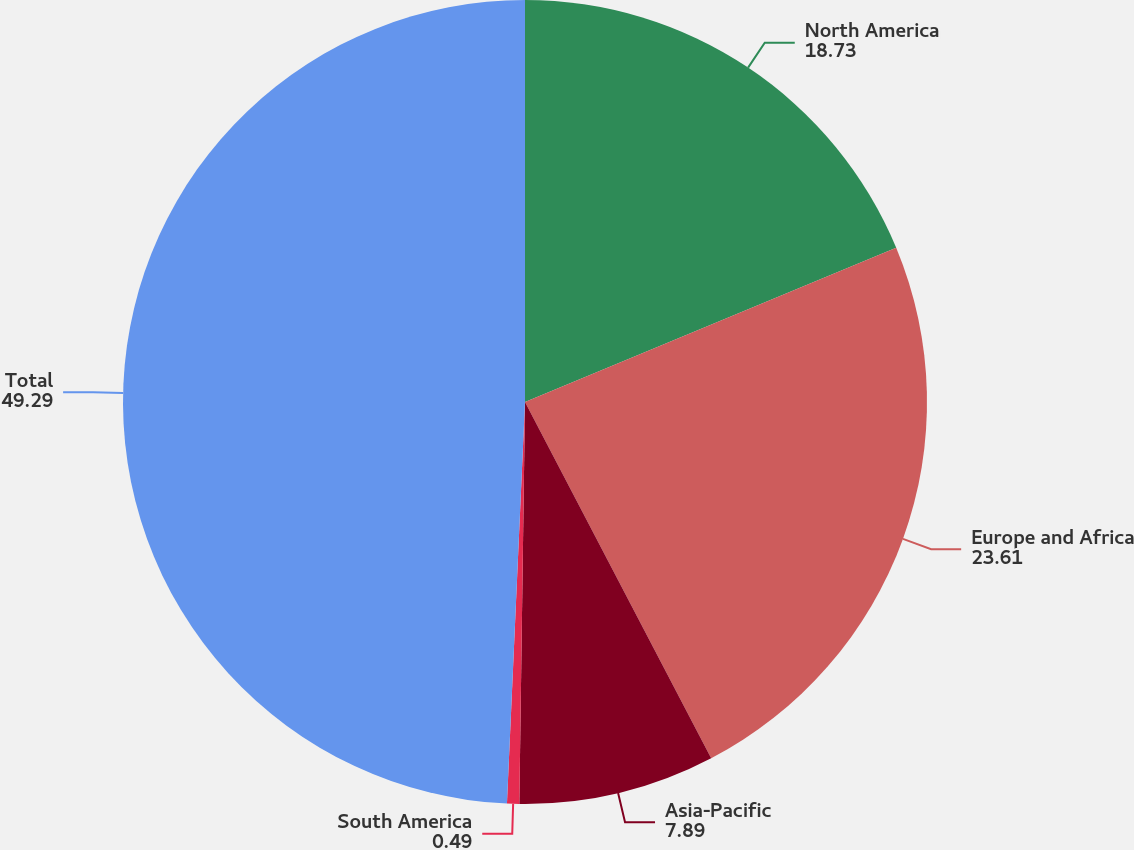Convert chart. <chart><loc_0><loc_0><loc_500><loc_500><pie_chart><fcel>North America<fcel>Europe and Africa<fcel>Asia-Pacific<fcel>South America<fcel>Total<nl><fcel>18.73%<fcel>23.61%<fcel>7.89%<fcel>0.49%<fcel>49.29%<nl></chart> 